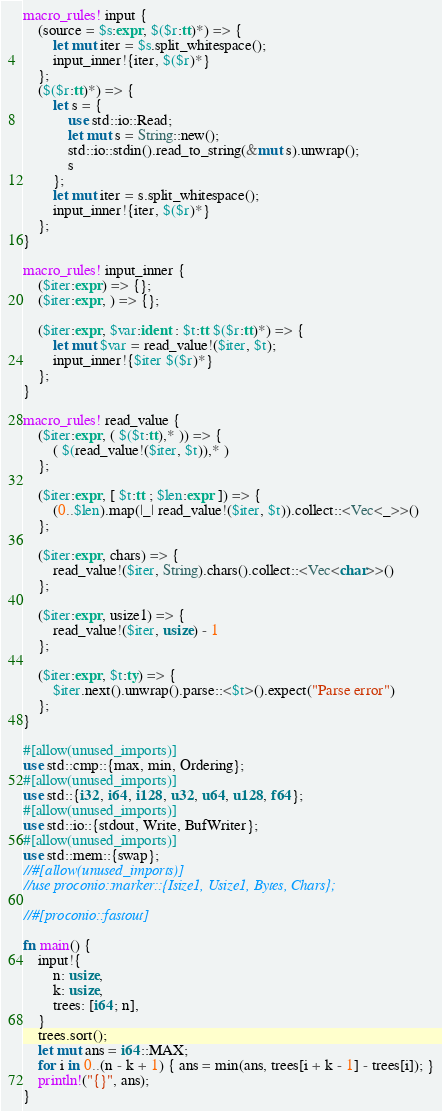<code> <loc_0><loc_0><loc_500><loc_500><_Rust_>macro_rules! input {
    (source = $s:expr, $($r:tt)*) => {
        let mut iter = $s.split_whitespace();
        input_inner!{iter, $($r)*}
    };
    ($($r:tt)*) => {
        let s = {
            use std::io::Read;
            let mut s = String::new();
            std::io::stdin().read_to_string(&mut s).unwrap();
            s
        };
        let mut iter = s.split_whitespace();
        input_inner!{iter, $($r)*}
    };
}

macro_rules! input_inner {
    ($iter:expr) => {};
    ($iter:expr, ) => {};

    ($iter:expr, $var:ident : $t:tt $($r:tt)*) => {
        let mut $var = read_value!($iter, $t);
        input_inner!{$iter $($r)*}
    };
}

macro_rules! read_value {
    ($iter:expr, ( $($t:tt),* )) => {
        ( $(read_value!($iter, $t)),* )
    };

    ($iter:expr, [ $t:tt ; $len:expr ]) => {
        (0..$len).map(|_| read_value!($iter, $t)).collect::<Vec<_>>()
    };

    ($iter:expr, chars) => {
        read_value!($iter, String).chars().collect::<Vec<char>>()
    };

    ($iter:expr, usize1) => {
        read_value!($iter, usize) - 1
    };

    ($iter:expr, $t:ty) => {
        $iter.next().unwrap().parse::<$t>().expect("Parse error")
    };
}

#[allow(unused_imports)]
use std::cmp::{max, min, Ordering};
#[allow(unused_imports)]
use std::{i32, i64, i128, u32, u64, u128, f64};
#[allow(unused_imports)]
use std::io::{stdout, Write, BufWriter};
#[allow(unused_imports)]
use std::mem::{swap};
//#[allow(unused_imports)]
//use proconio::marker::{Isize1, Usize1, Bytes, Chars};

//#[proconio::fastout]

fn main() {
    input!{
        n: usize,
        k: usize,
        trees: [i64; n],
    }
    trees.sort();
    let mut ans = i64::MAX;
    for i in 0..(n - k + 1) { ans = min(ans, trees[i + k - 1] - trees[i]); }
    println!("{}", ans);
}

</code> 